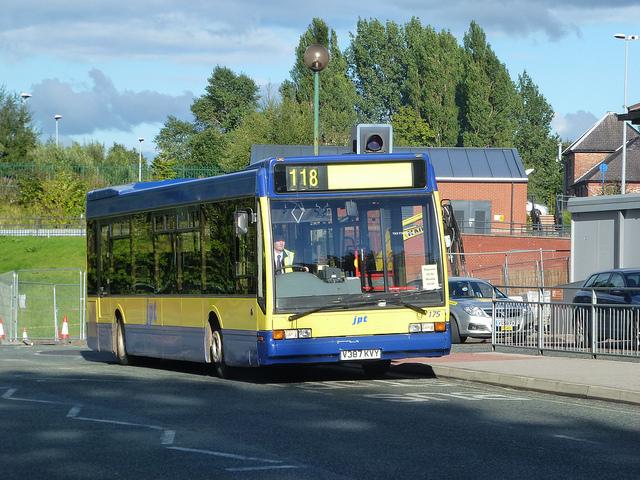Is this a city scene?
Quick response, please. No. What number is on the bus?
Give a very brief answer. 118. Do the tires on this vehicle contain the proper amount of air?
Keep it brief. Yes. Is the driver visible?
Write a very short answer. Yes. Is there construction nearby?
Keep it brief. No. What type of scene is this?
Give a very brief answer. Bus stop. What is behind the metal fence?
Be succinct. Cars. What number is this bus?
Quick response, please. 118. 